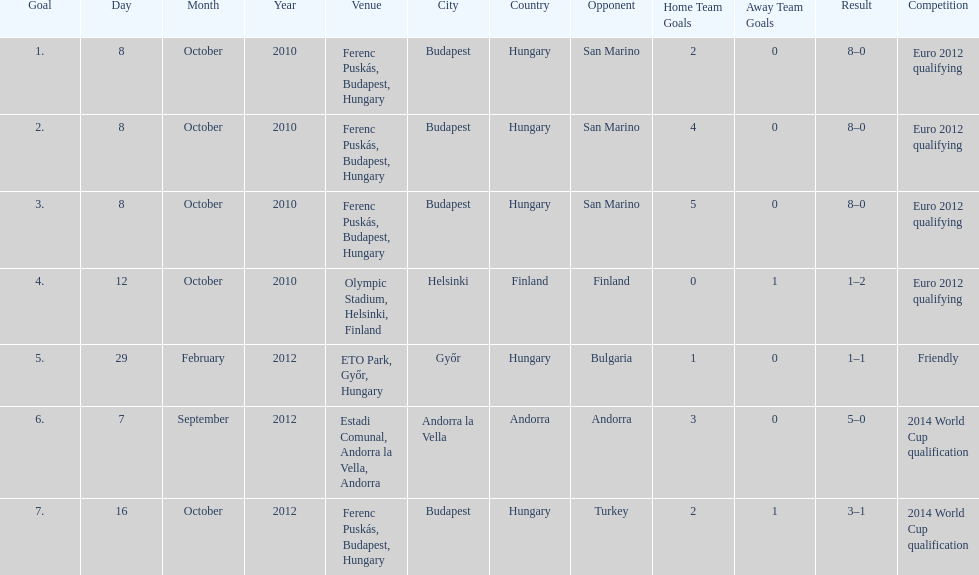Would you be able to parse every entry in this table? {'header': ['Goal', 'Day', 'Month', 'Year', 'Venue', 'City', 'Country', 'Opponent', 'Home Team Goals', 'Away Team Goals', 'Result', 'Competition'], 'rows': [['1.', '8', 'October', '2010', 'Ferenc Puskás, Budapest, Hungary', 'Budapest', 'Hungary', 'San Marino', '2', '0', '8–0', 'Euro 2012 qualifying'], ['2.', '8', 'October', '2010', 'Ferenc Puskás, Budapest, Hungary', 'Budapest', 'Hungary', 'San Marino', '4', '0', '8–0', 'Euro 2012 qualifying'], ['3.', '8', 'October', '2010', 'Ferenc Puskás, Budapest, Hungary', 'Budapest', 'Hungary', 'San Marino', '5', '0', '8–0', 'Euro 2012 qualifying'], ['4.', '12', 'October', '2010', 'Olympic Stadium, Helsinki, Finland', 'Helsinki', 'Finland', 'Finland', '0', '1', '1–2', 'Euro 2012 qualifying'], ['5.', '29', 'February', '2012', 'ETO Park, Győr, Hungary', 'Győr', 'Hungary', 'Bulgaria', '1', '0', '1–1', 'Friendly'], ['6.', '7', 'September', '2012', 'Estadi Comunal, Andorra la Vella, Andorra', 'Andorra la Vella', 'Andorra', 'Andorra', '3', '0', '5–0', '2014 World Cup qualification'], ['7.', '16', 'October', '2012', 'Ferenc Puskás, Budapest, Hungary', 'Budapest', 'Hungary', 'Turkey', '2', '1', '3–1', '2014 World Cup qualification']]} Szalai scored all but one of his international goals in either euro 2012 qualifying or what other level of play? 2014 World Cup qualification. 